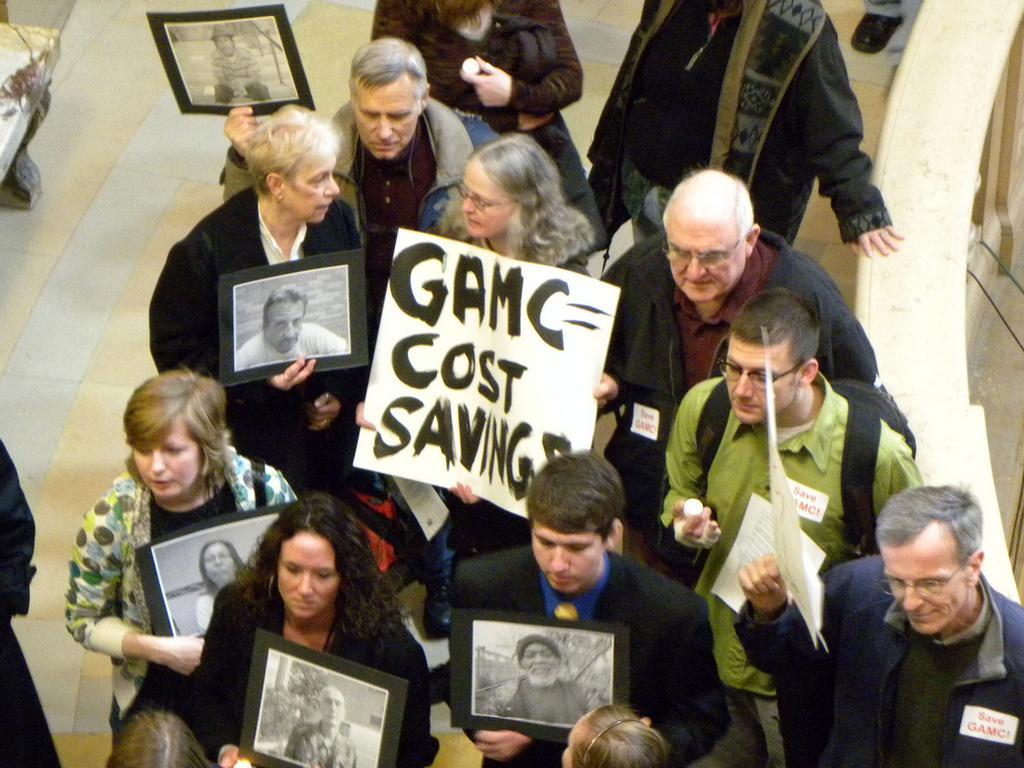How would you summarize this image in a sentence or two? In this picture there are group of people standing and holding the papers and there is text and there are pictures of the people on the papers. On the left side of the image it looks like a chair. At the bottom there is a floor. On the right side of the image it looks like a table. 